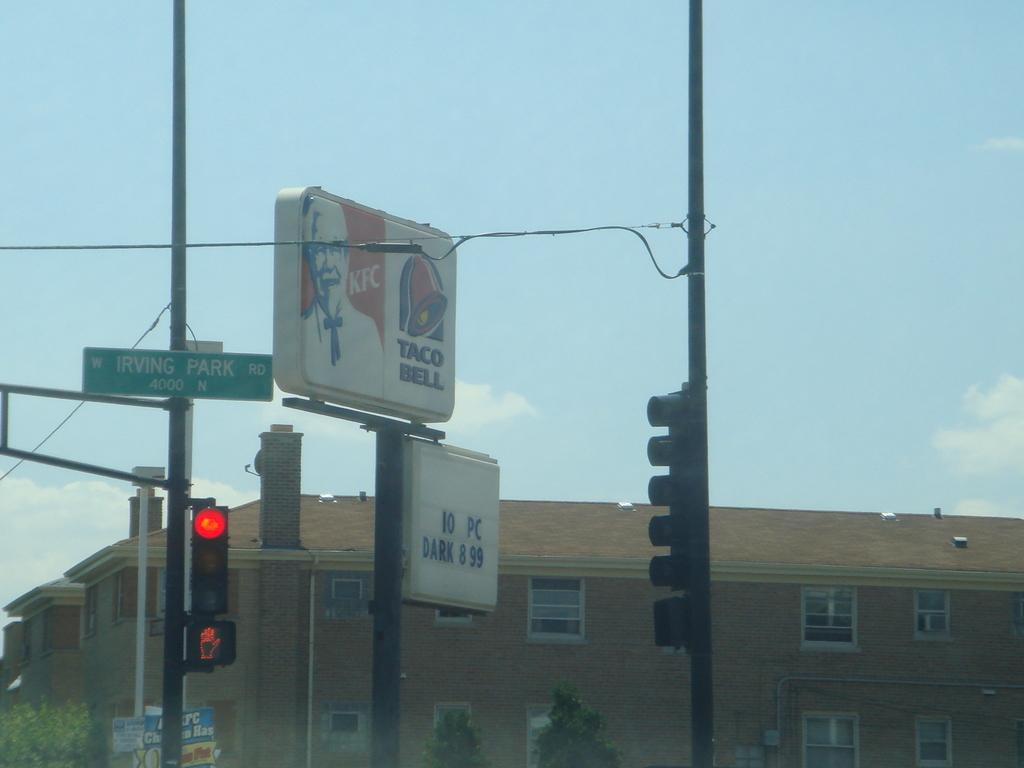<image>
Render a clear and concise summary of the photo. A KFC and Taco Bell sign is on a pole on Irving Park Road. 